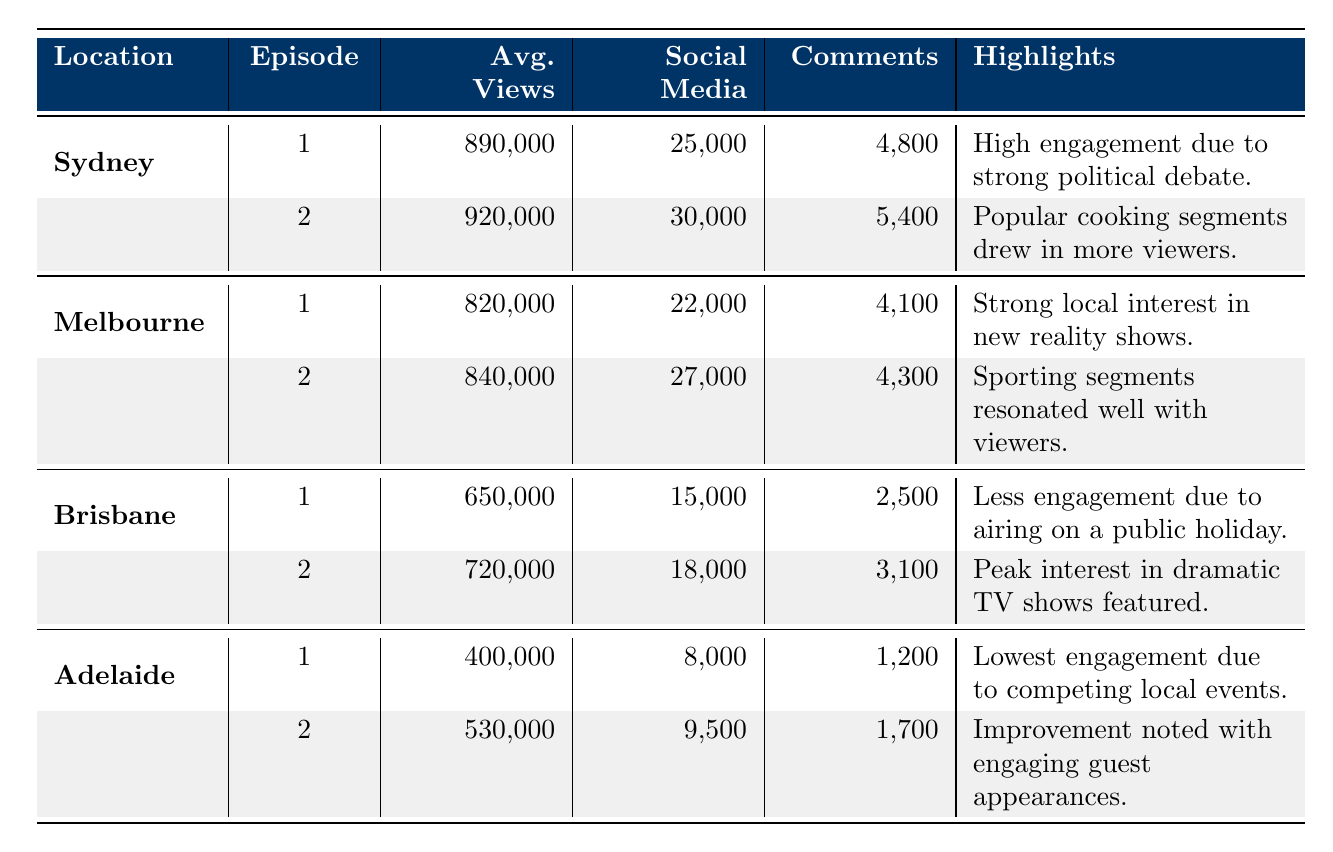What was the episode with the highest average views in Sydney? Episode 2 had the highest average views in Sydney, with 920,000 viewers. This can be seen in the row for Sydney, Episode 2, where the average views are listed.
Answer: 920,000 How many total comments were made on Gogglebox episodes aired in Melbourne? The total comments for Melbourne can be calculated by adding the comments from both episodes: 4,100 (Episode 1) + 4,300 (Episode 2) = 8,400.
Answer: 8,400 Did Brisbane's first episode have more or fewer average views than Adelaide's first episode? Brisbane's first episode had 650,000 average views, while Adelaide's first episode had 400,000 average views. Comparing these values shows that Brisbane's episode had more views.
Answer: More What was the total number of social media interactions for all episodes in Adelaide? To find the total social media interactions for Adelaide, add the interactions from both episodes: 8,000 (Episode 1) + 9,500 (Episode 2) = 17,500.
Answer: 17,500 Which location had the highest viewer engagement based on average views in episode 1? To answer this, compare the average views of Episode 1 for each location: Sydney (890,000), Melbourne (820,000), Brisbane (650,000), and Adelaide (400,000). Sydney had the highest average views among them.
Answer: Sydney Which episode in Sydney had the highest number of social media interactions? Looking at the social media interactions for Sydney, Episode 2 had 30,000 interactions, which is higher than Episode 1's 25,000 interactions. Thus, Episode 2 had the highest number.
Answer: Episode 2 Did the engagement for Gogglebox episodes improve from Episode 1 to Episode 2 in Adelaide? In Adelaide, Episode 1 had 400,000 average views and Episode 2 had 530,000 average views. Since 530,000 is greater than 400,000, the engagement did improve from Episode 1 to Episode 2.
Answer: Yes What is the difference in average views between Sydney's first episode and Brisbane's second episode? The average views for Sydney's first episode are 890,000 and for Brisbane's second episode are 720,000. To find the difference, subtract 720,000 from 890,000, which equals 170,000.
Answer: 170,000 Which city had the least viewer engagement based on social media interactions in both episodes combined? To find the city with the least engagement based on social media interactions, we calculate the total for each city: Sydney (55,000), Melbourne (49,000), Brisbane (33,000), and Adelaide (17,500). Adelaide had the least with 17,500 combined interactions.
Answer: Adelaide 